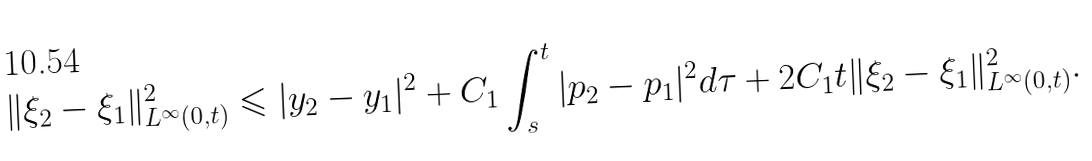<formula> <loc_0><loc_0><loc_500><loc_500>\| \xi _ { 2 } - \xi _ { 1 } \| ^ { 2 } _ { L ^ { \infty } ( 0 , t ) } \leqslant | y _ { 2 } - y _ { 1 } | ^ { 2 } + C _ { 1 } \int ^ { t } _ { s } | p _ { 2 } - p _ { 1 } | ^ { 2 } d \tau + 2 C _ { 1 } t \| \xi _ { 2 } - \xi _ { 1 } \| ^ { 2 } _ { L ^ { \infty } ( 0 , t ) } .</formula> 